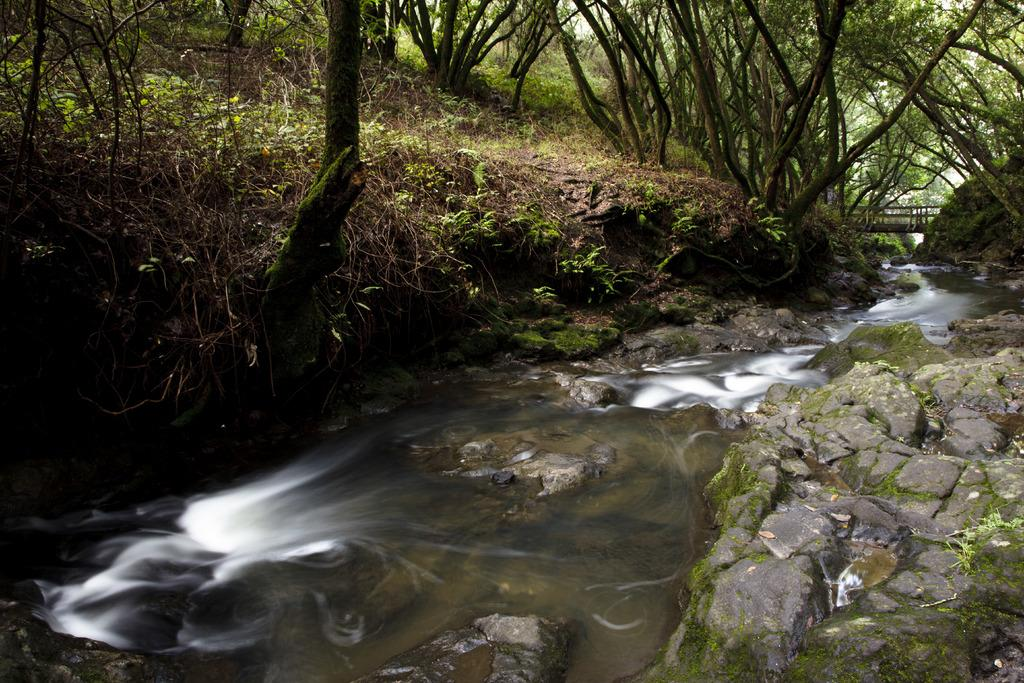What type of vegetation can be seen in the image? There are trees in the image. What is the ground covered with in the image? There is grass in the image. What can be seen in the water in the image? There are stones in the image. What structure is present in the image that allows people to cross the water? There is a bridge in the image. How many rabbits can be seen hopping around in the image? There are no rabbits present in the image. What type of force is being applied to the trees in the image? There is no force being applied to the trees in the image; they are stationary. 